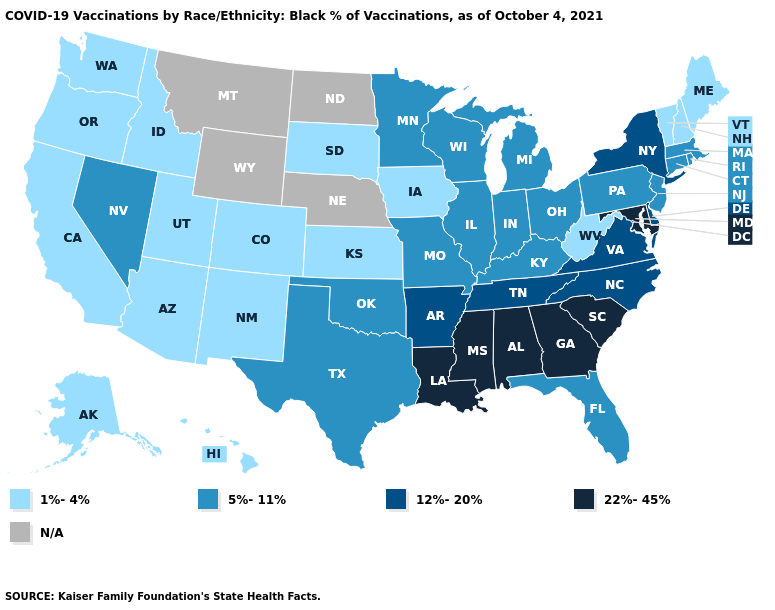Name the states that have a value in the range N/A?
Be succinct. Montana, Nebraska, North Dakota, Wyoming. Name the states that have a value in the range 12%-20%?
Write a very short answer. Arkansas, Delaware, New York, North Carolina, Tennessee, Virginia. Which states have the highest value in the USA?
Give a very brief answer. Alabama, Georgia, Louisiana, Maryland, Mississippi, South Carolina. Does Missouri have the lowest value in the MidWest?
Concise answer only. No. What is the value of Louisiana?
Be succinct. 22%-45%. Among the states that border Oregon , which have the lowest value?
Keep it brief. California, Idaho, Washington. Name the states that have a value in the range 1%-4%?
Be succinct. Alaska, Arizona, California, Colorado, Hawaii, Idaho, Iowa, Kansas, Maine, New Hampshire, New Mexico, Oregon, South Dakota, Utah, Vermont, Washington, West Virginia. What is the highest value in the Northeast ?
Quick response, please. 12%-20%. Name the states that have a value in the range 12%-20%?
Keep it brief. Arkansas, Delaware, New York, North Carolina, Tennessee, Virginia. Does the first symbol in the legend represent the smallest category?
Be succinct. Yes. What is the value of Illinois?
Keep it brief. 5%-11%. Does New York have the highest value in the Northeast?
Answer briefly. Yes. Does California have the lowest value in the West?
Keep it brief. Yes. Among the states that border New Hampshire , which have the lowest value?
Write a very short answer. Maine, Vermont. Name the states that have a value in the range 1%-4%?
Give a very brief answer. Alaska, Arizona, California, Colorado, Hawaii, Idaho, Iowa, Kansas, Maine, New Hampshire, New Mexico, Oregon, South Dakota, Utah, Vermont, Washington, West Virginia. 